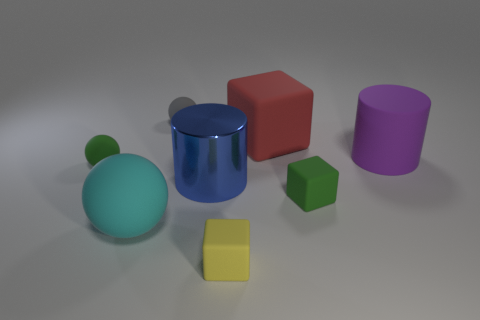What is the shape of the tiny rubber thing behind the green rubber object that is behind the small matte thing that is on the right side of the yellow object?
Keep it short and to the point. Sphere. Does the rubber cube to the left of the red matte thing have the same size as the cyan ball?
Ensure brevity in your answer.  No. What is the shape of the rubber thing that is behind the big blue cylinder and to the left of the gray thing?
Your answer should be very brief. Sphere. Do the large metal thing and the block to the left of the red block have the same color?
Offer a very short reply. No. What color is the big rubber cylinder that is on the right side of the blue thing to the left of the rubber thing to the right of the green rubber cube?
Offer a very short reply. Purple. What color is the other big thing that is the same shape as the big purple rubber object?
Keep it short and to the point. Blue. Are there the same number of matte objects that are behind the purple matte cylinder and cyan rubber objects?
Make the answer very short. No. What number of cubes are small things or shiny things?
Provide a short and direct response. 2. There is a large cube that is made of the same material as the purple cylinder; what color is it?
Offer a very short reply. Red. Are the large cyan ball and the large cylinder that is behind the small green ball made of the same material?
Your response must be concise. Yes. 